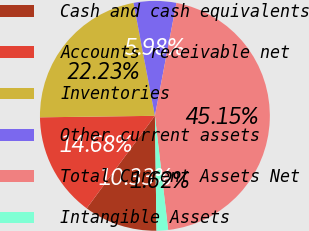<chart> <loc_0><loc_0><loc_500><loc_500><pie_chart><fcel>Cash and cash equivalents<fcel>Accounts receivable net<fcel>Inventories<fcel>Other current assets<fcel>Total Current Assets Net<fcel>Intangible Assets<nl><fcel>10.33%<fcel>14.68%<fcel>22.23%<fcel>5.98%<fcel>45.15%<fcel>1.62%<nl></chart> 